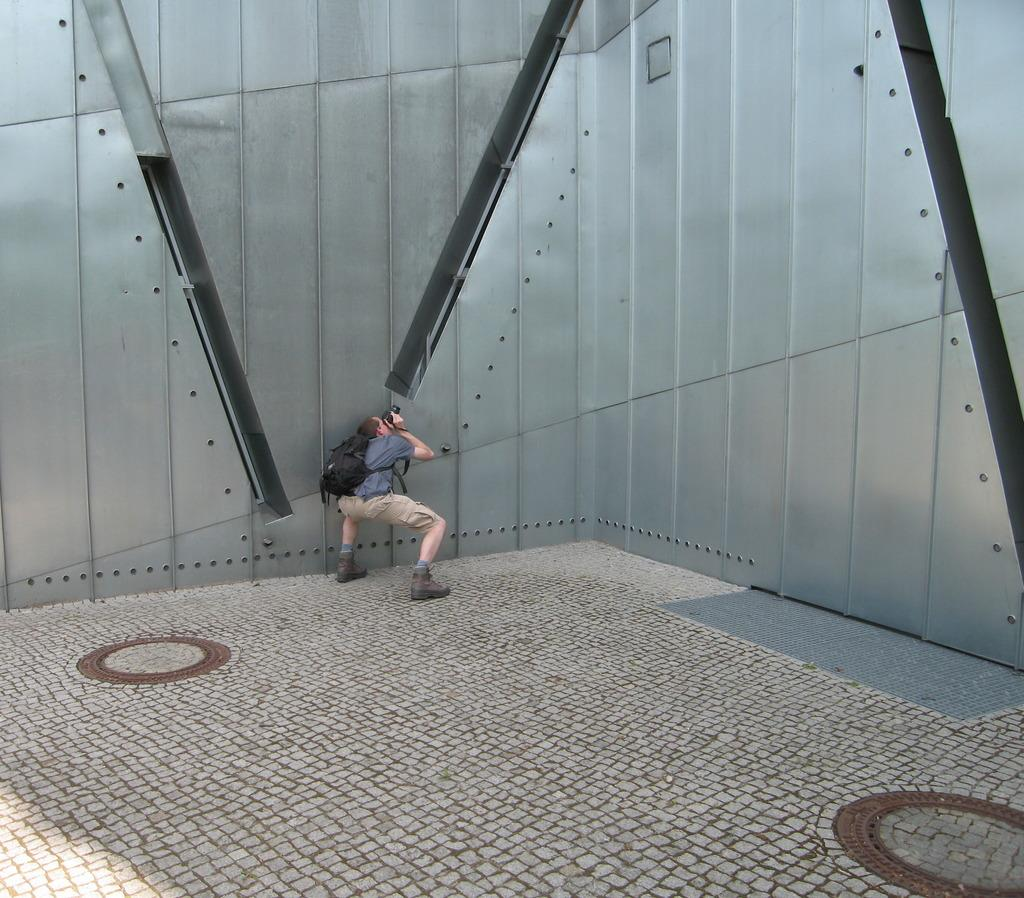What can be seen in the image related to a person? There is a person in the image, and they are carrying a bag and holding an object. What is the person standing on in the image? There is ground visible in the image, which the person is standing on. What type of structure is present in the image? There is a metal wall in the image. What type of copper object is being held by the person in the image? There is no copper object present in the image. Can you describe the flesh of the person in the image? The image does not provide enough detail to describe the person's flesh. 